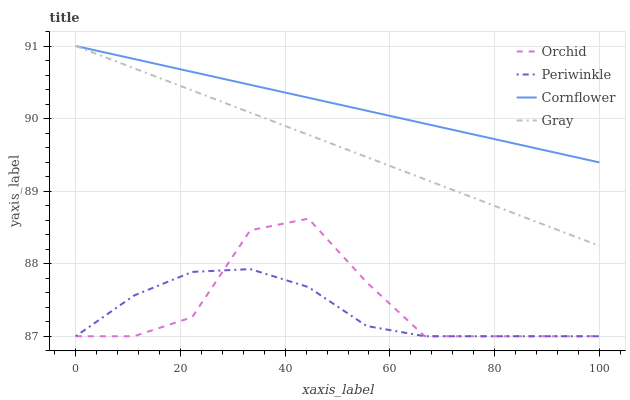Does Gray have the minimum area under the curve?
Answer yes or no. No. Does Gray have the maximum area under the curve?
Answer yes or no. No. Is Gray the smoothest?
Answer yes or no. No. Is Gray the roughest?
Answer yes or no. No. Does Gray have the lowest value?
Answer yes or no. No. Does Periwinkle have the highest value?
Answer yes or no. No. Is Periwinkle less than Gray?
Answer yes or no. Yes. Is Gray greater than Periwinkle?
Answer yes or no. Yes. Does Periwinkle intersect Gray?
Answer yes or no. No. 